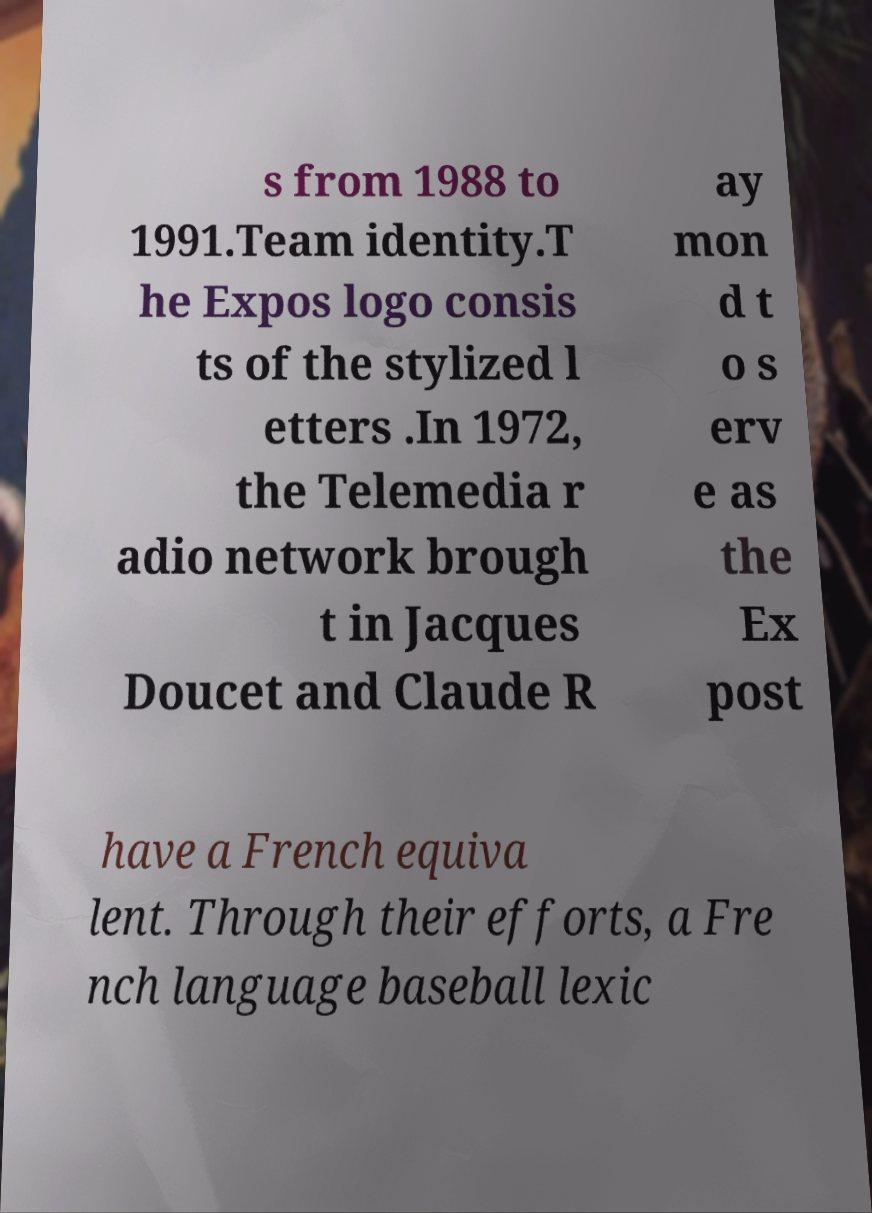Could you extract and type out the text from this image? s from 1988 to 1991.Team identity.T he Expos logo consis ts of the stylized l etters .In 1972, the Telemedia r adio network brough t in Jacques Doucet and Claude R ay mon d t o s erv e as the Ex post have a French equiva lent. Through their efforts, a Fre nch language baseball lexic 